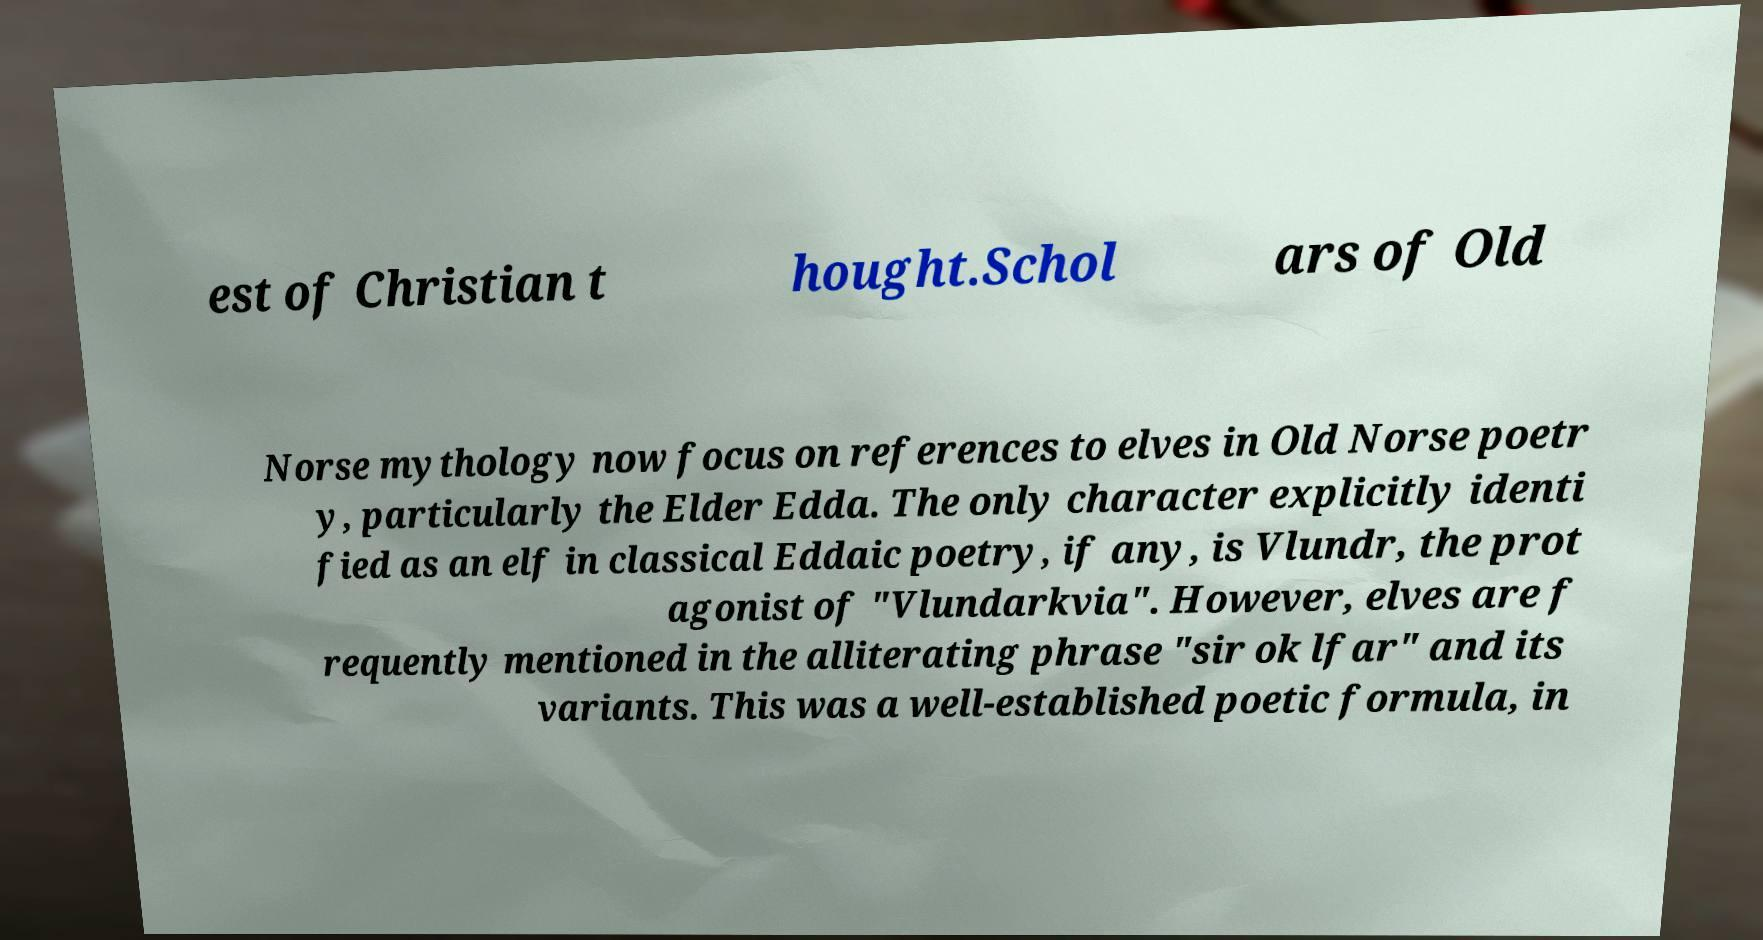For documentation purposes, I need the text within this image transcribed. Could you provide that? est of Christian t hought.Schol ars of Old Norse mythology now focus on references to elves in Old Norse poetr y, particularly the Elder Edda. The only character explicitly identi fied as an elf in classical Eddaic poetry, if any, is Vlundr, the prot agonist of "Vlundarkvia". However, elves are f requently mentioned in the alliterating phrase "sir ok lfar" and its variants. This was a well-established poetic formula, in 